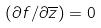<formula> <loc_0><loc_0><loc_500><loc_500>( \partial f / \partial \overline { z } ) = 0</formula> 